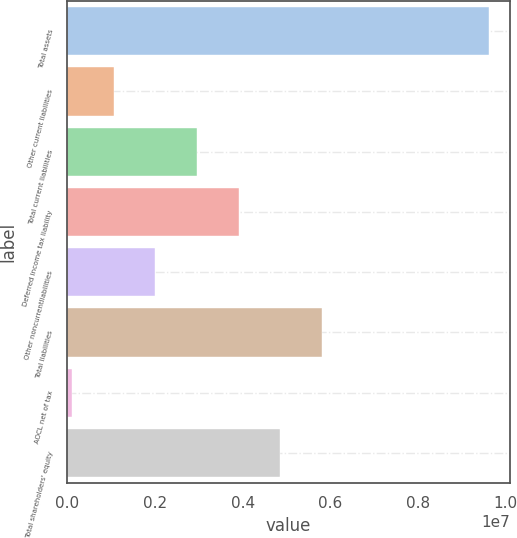Convert chart to OTSL. <chart><loc_0><loc_0><loc_500><loc_500><bar_chart><fcel>Total assets<fcel>Other current liabilities<fcel>Total current liabilities<fcel>Deferred income tax liability<fcel>Other noncurrentliabilities<fcel>Total liabilities<fcel>AOCL net of tax<fcel>Total shareholders' equity<nl><fcel>9.61372e+06<fcel>1.05777e+06<fcel>2.95909e+06<fcel>3.90975e+06<fcel>2.00843e+06<fcel>5.81107e+06<fcel>107108<fcel>4.86041e+06<nl></chart> 